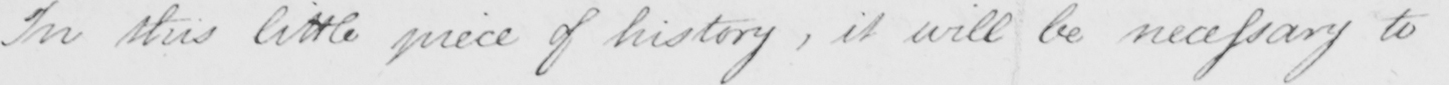What text is written in this handwritten line? In this little piece of history , it will be necessary to 